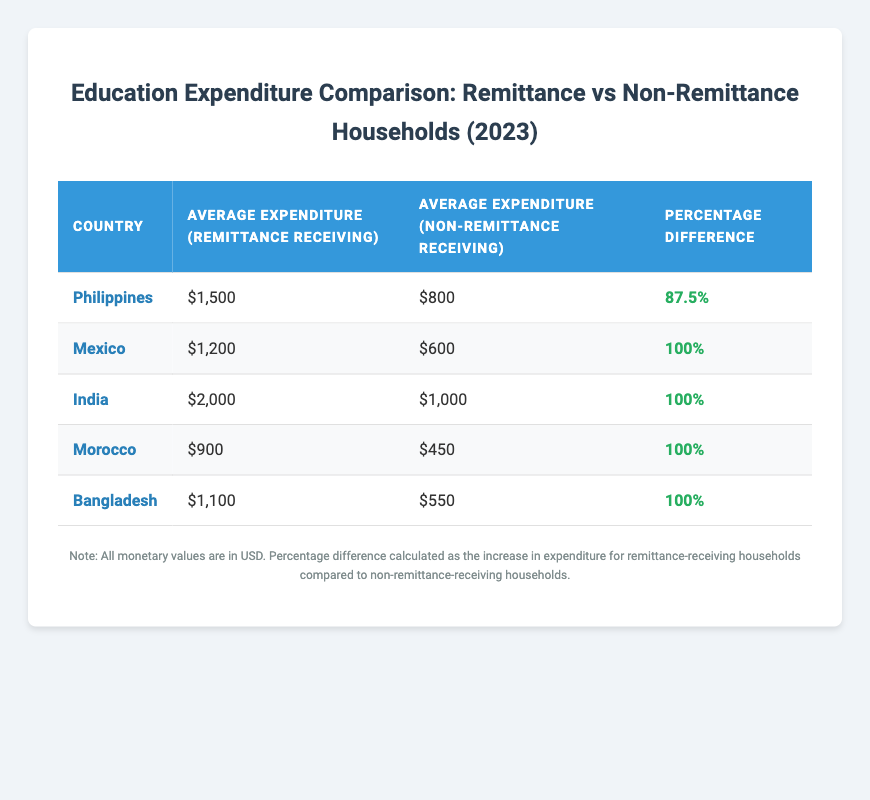What is the average expenditure for remittance receiving households in the Philippines? From the table, the average expenditure for remittance receiving households in the Philippines is listed as $1,500.
Answer: $1,500 What is the percentage difference in education expenditure between remittance receiving and non-remittance receiving households in India? The table shows that the percentage difference in education expenditure in India is 100%.
Answer: 100% Which country has the lowest average expenditure for non-remittance receiving households? The table indicates that Morocco has the lowest average expenditure for non-remittance receiving households at $450.
Answer: $450 How much more do remittance receiving households spend on education compared to non-remittance receiving households in Bangladesh? The average expenditure for remittance receiving households in Bangladesh is $1,100 and for non-remittance receiving households is $550. The difference is $1,100 - $550 = $550.
Answer: $550 Is the percentage difference in expenditure the same for all countries in the table? The table shows that all countries except the Philippines have a percentage difference of 100%, indicating that it is not the same across all countries.
Answer: No Which country's remittance receiving households have the highest average expenditure? According to the table, Indian households receiving remittances have the highest average expenditure at $2,000.
Answer: $2,000 If we sum the average expenditure of remittance receiving households across all listed countries, what amount do we get? The expenditures are $1,500 (Philippines) + $1,200 (Mexico) + $2,000 (India) + $900 (Morocco) + $1,100 (Bangladesh) = $6,700.
Answer: $6,700 What is the difference in average expenditure between remittance receiving households and non-remittance receiving households in Mexico? For Mexico, the average expenditure for remittance receiving households is $1,200 and for non-remittance receiving households is $600. The difference is $1,200 - $600 = $600.
Answer: $600 Do all countries have a higher average expenditure for remittance receiving households compared to non-remittance receiving households? The data shows that in every case, the expenditure of remittance receiving households is higher than that of non-remittance receiving households, confirming this statement is true.
Answer: Yes 